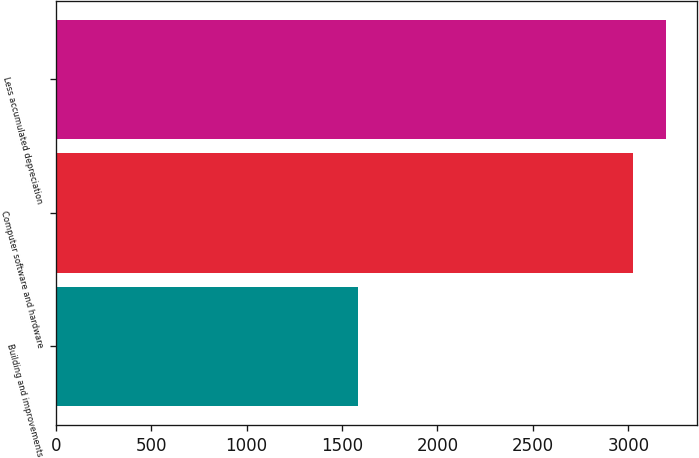Convert chart to OTSL. <chart><loc_0><loc_0><loc_500><loc_500><bar_chart><fcel>Building and improvements<fcel>Computer software and hardware<fcel>Less accumulated depreciation<nl><fcel>1581<fcel>3022<fcel>3198<nl></chart> 